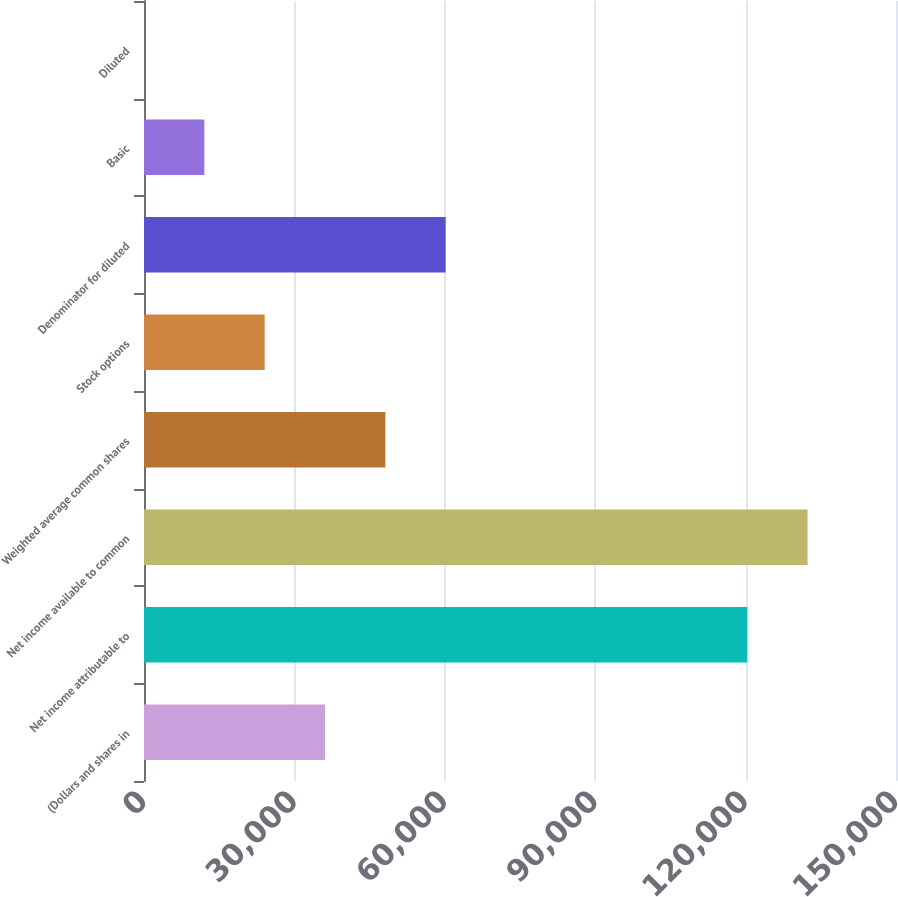<chart> <loc_0><loc_0><loc_500><loc_500><bar_chart><fcel>(Dollars and shares in<fcel>Net income attributable to<fcel>Net income available to common<fcel>Weighted average common shares<fcel>Stock options<fcel>Denominator for diluted<fcel>Basic<fcel>Diluted<nl><fcel>36101<fcel>120329<fcel>132362<fcel>48133.6<fcel>24068.4<fcel>60166.1<fcel>12035.9<fcel>3.28<nl></chart> 